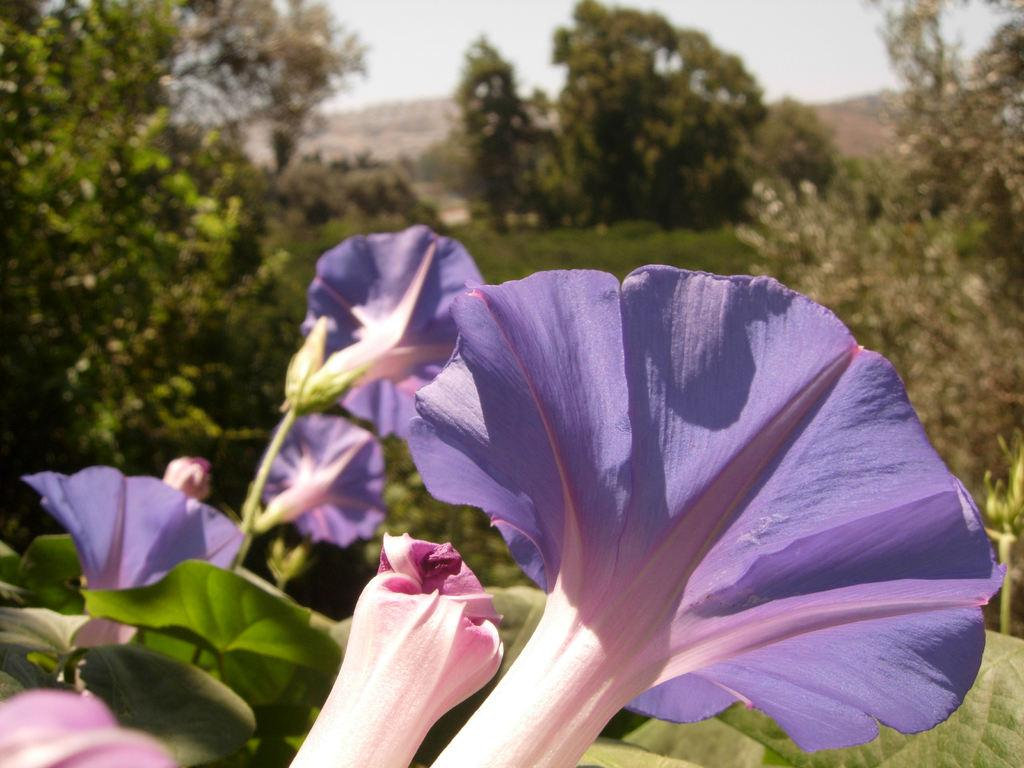What type of vegetation is in the front of the image? There are flowers and leaves in the front of the image. What can be seen in the background of the image? There are trees, grass, and the sky visible in the background of the image. How many centimeters does the error in the image measure? There is no error present in the image, so it cannot be measured. What type of voyage is depicted in the image? There is no voyage depicted in the image; it features flowers, leaves, trees, grass, and the sky. 